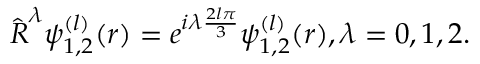Convert formula to latex. <formula><loc_0><loc_0><loc_500><loc_500>\hat { R } ^ { \lambda } \psi _ { 1 , 2 } ^ { ( l ) } ( r ) = e ^ { i \lambda \frac { 2 l \pi } { 3 } } \psi _ { 1 , 2 } ^ { ( l ) } ( r ) , \lambda = 0 , 1 , 2 .</formula> 